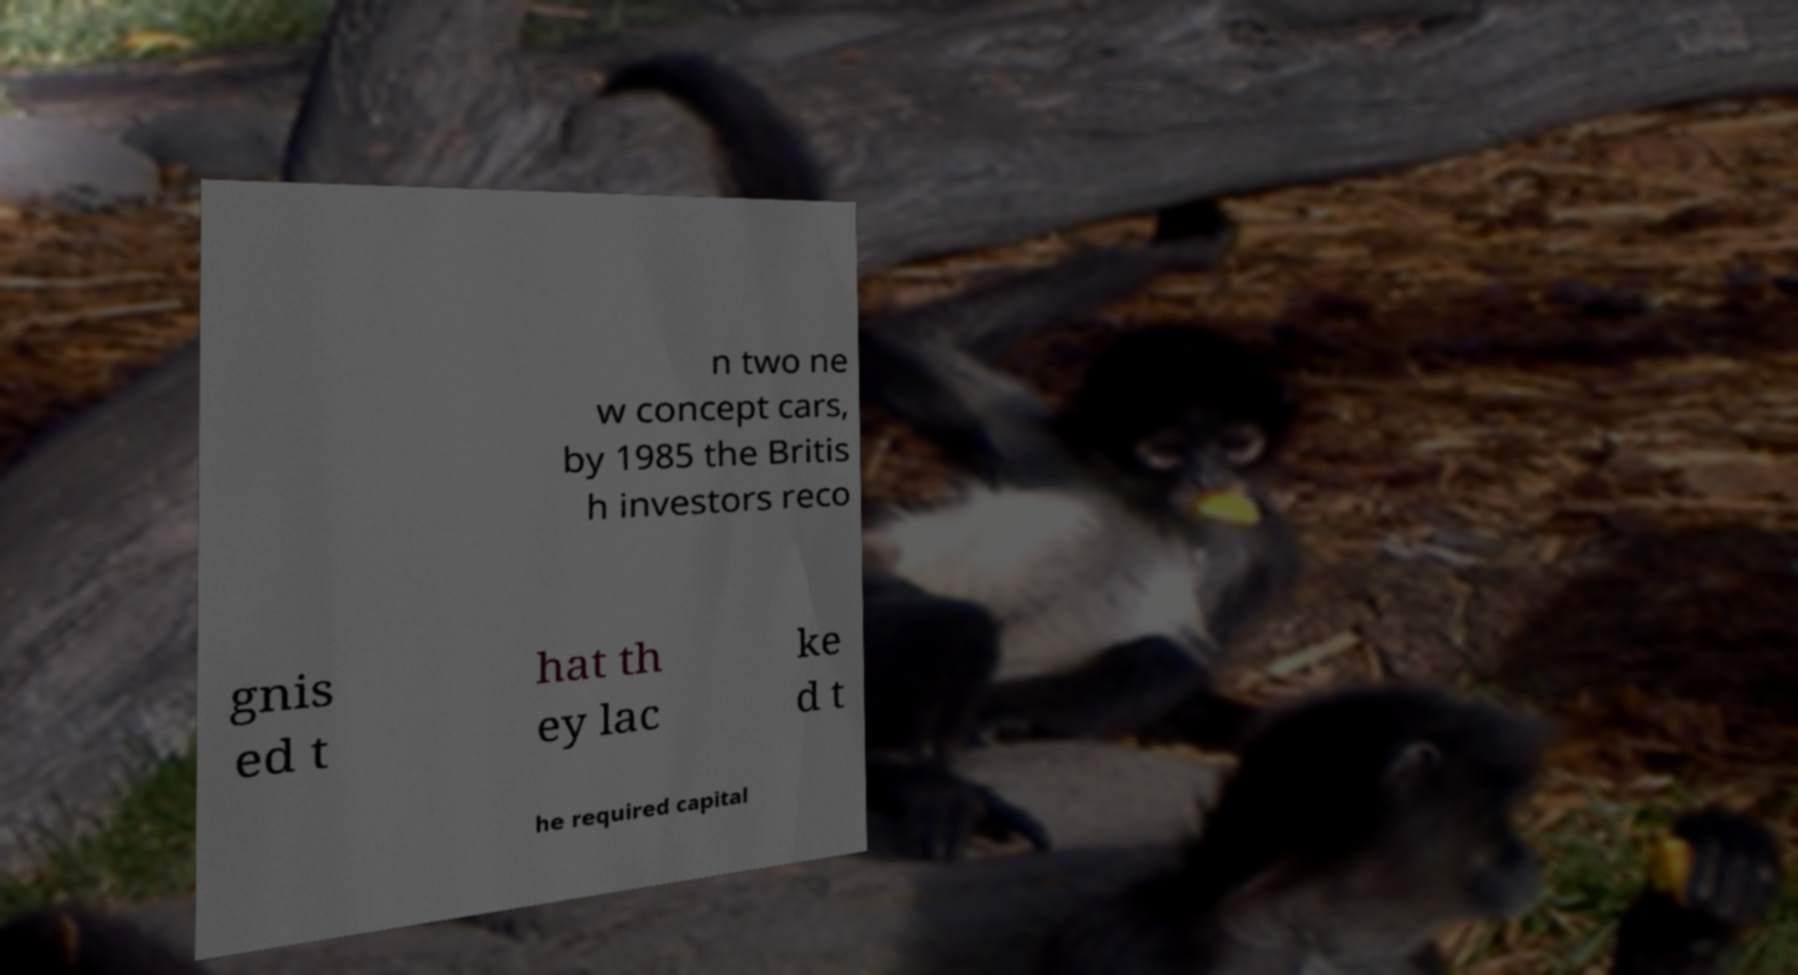Please read and relay the text visible in this image. What does it say? n two ne w concept cars, by 1985 the Britis h investors reco gnis ed t hat th ey lac ke d t he required capital 